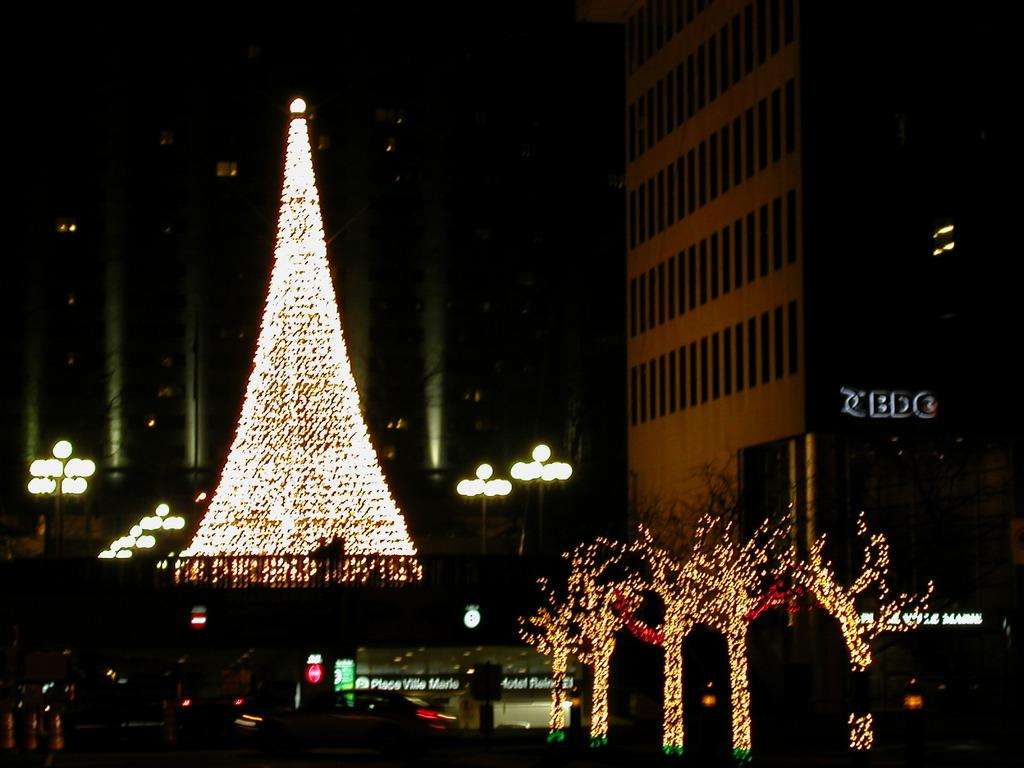What type of objects can be seen in the image that provide illumination? There are lights in the image. What type of natural elements can be seen in the image? There are trees in the image. What type of structures can be seen in the image that support the lights or other objects? There are poles in the image. What type of advertising or informational signs can be seen in the image? There are hoardings in the image. What type of man-made structures can be seen in the image that are used for various purposes? There are buildings in the image. Can you tell me how many girls are holding a tin heart in the image? There are no girls or tin hearts present in the image; it features lights, trees, poles, hoardings, and buildings. 